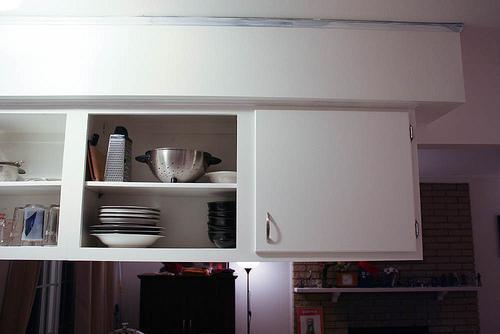How many cheese graters are in the cabinet?
Give a very brief answer. 1. How many large white bowls are in the stack?
Give a very brief answer. 3. How many small black bowls are there?
Give a very brief answer. 5. How many containers are a metal bowl?
Give a very brief answer. 1. 